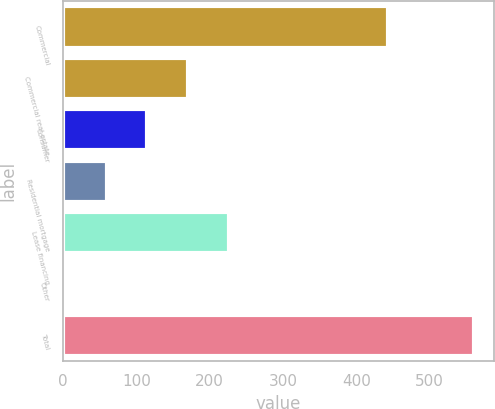Convert chart to OTSL. <chart><loc_0><loc_0><loc_500><loc_500><bar_chart><fcel>Commercial<fcel>Commercial real estate<fcel>Consumer<fcel>Residential mortgage<fcel>Lease financing<fcel>Other<fcel>Total<nl><fcel>443<fcel>170.8<fcel>115.2<fcel>59.6<fcel>226.4<fcel>4<fcel>560<nl></chart> 